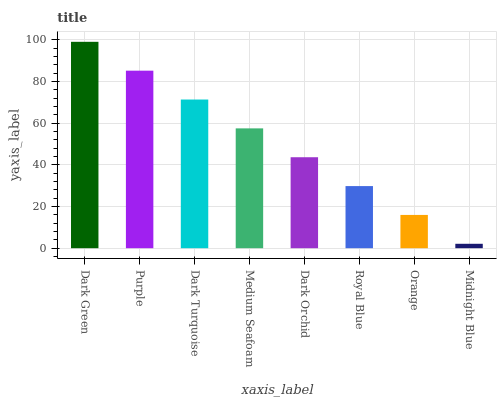Is Midnight Blue the minimum?
Answer yes or no. Yes. Is Dark Green the maximum?
Answer yes or no. Yes. Is Purple the minimum?
Answer yes or no. No. Is Purple the maximum?
Answer yes or no. No. Is Dark Green greater than Purple?
Answer yes or no. Yes. Is Purple less than Dark Green?
Answer yes or no. Yes. Is Purple greater than Dark Green?
Answer yes or no. No. Is Dark Green less than Purple?
Answer yes or no. No. Is Medium Seafoam the high median?
Answer yes or no. Yes. Is Dark Orchid the low median?
Answer yes or no. Yes. Is Royal Blue the high median?
Answer yes or no. No. Is Midnight Blue the low median?
Answer yes or no. No. 